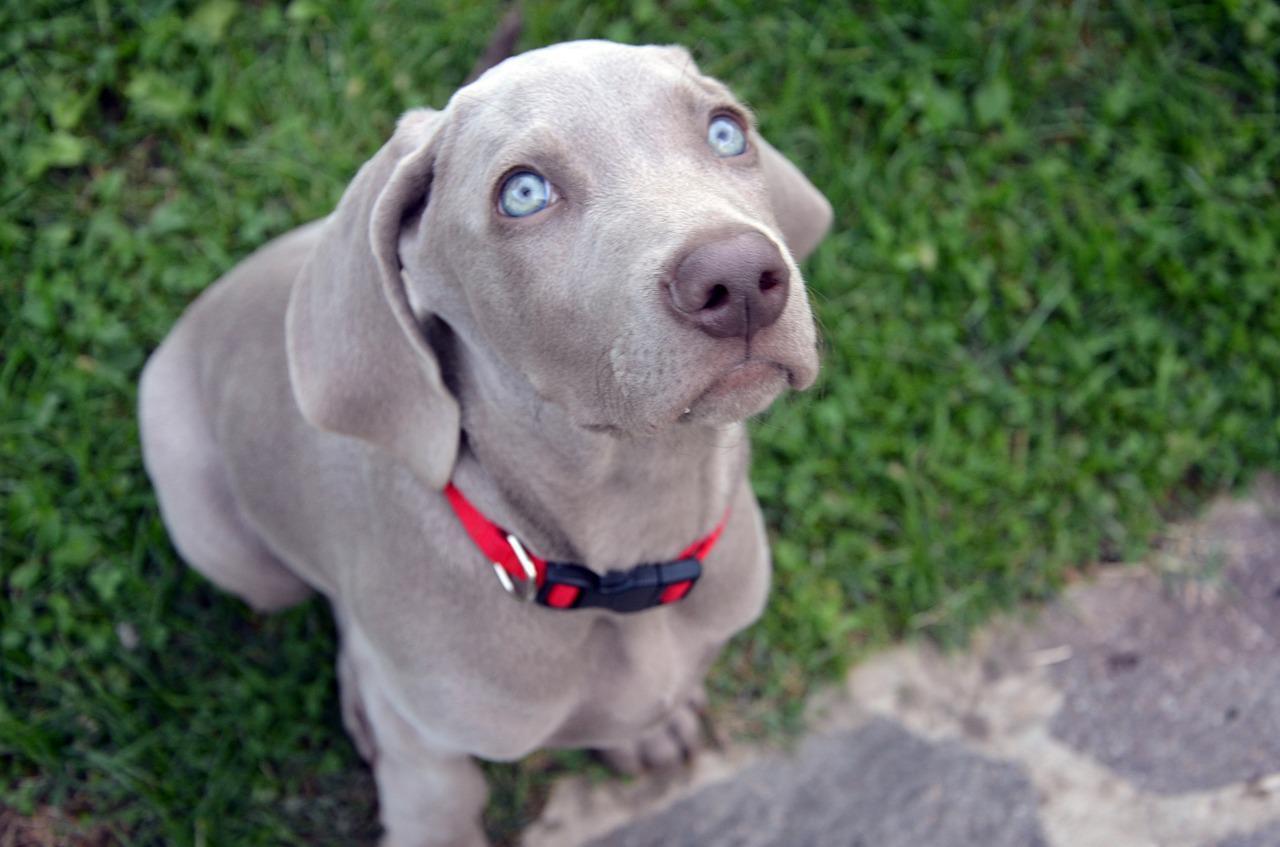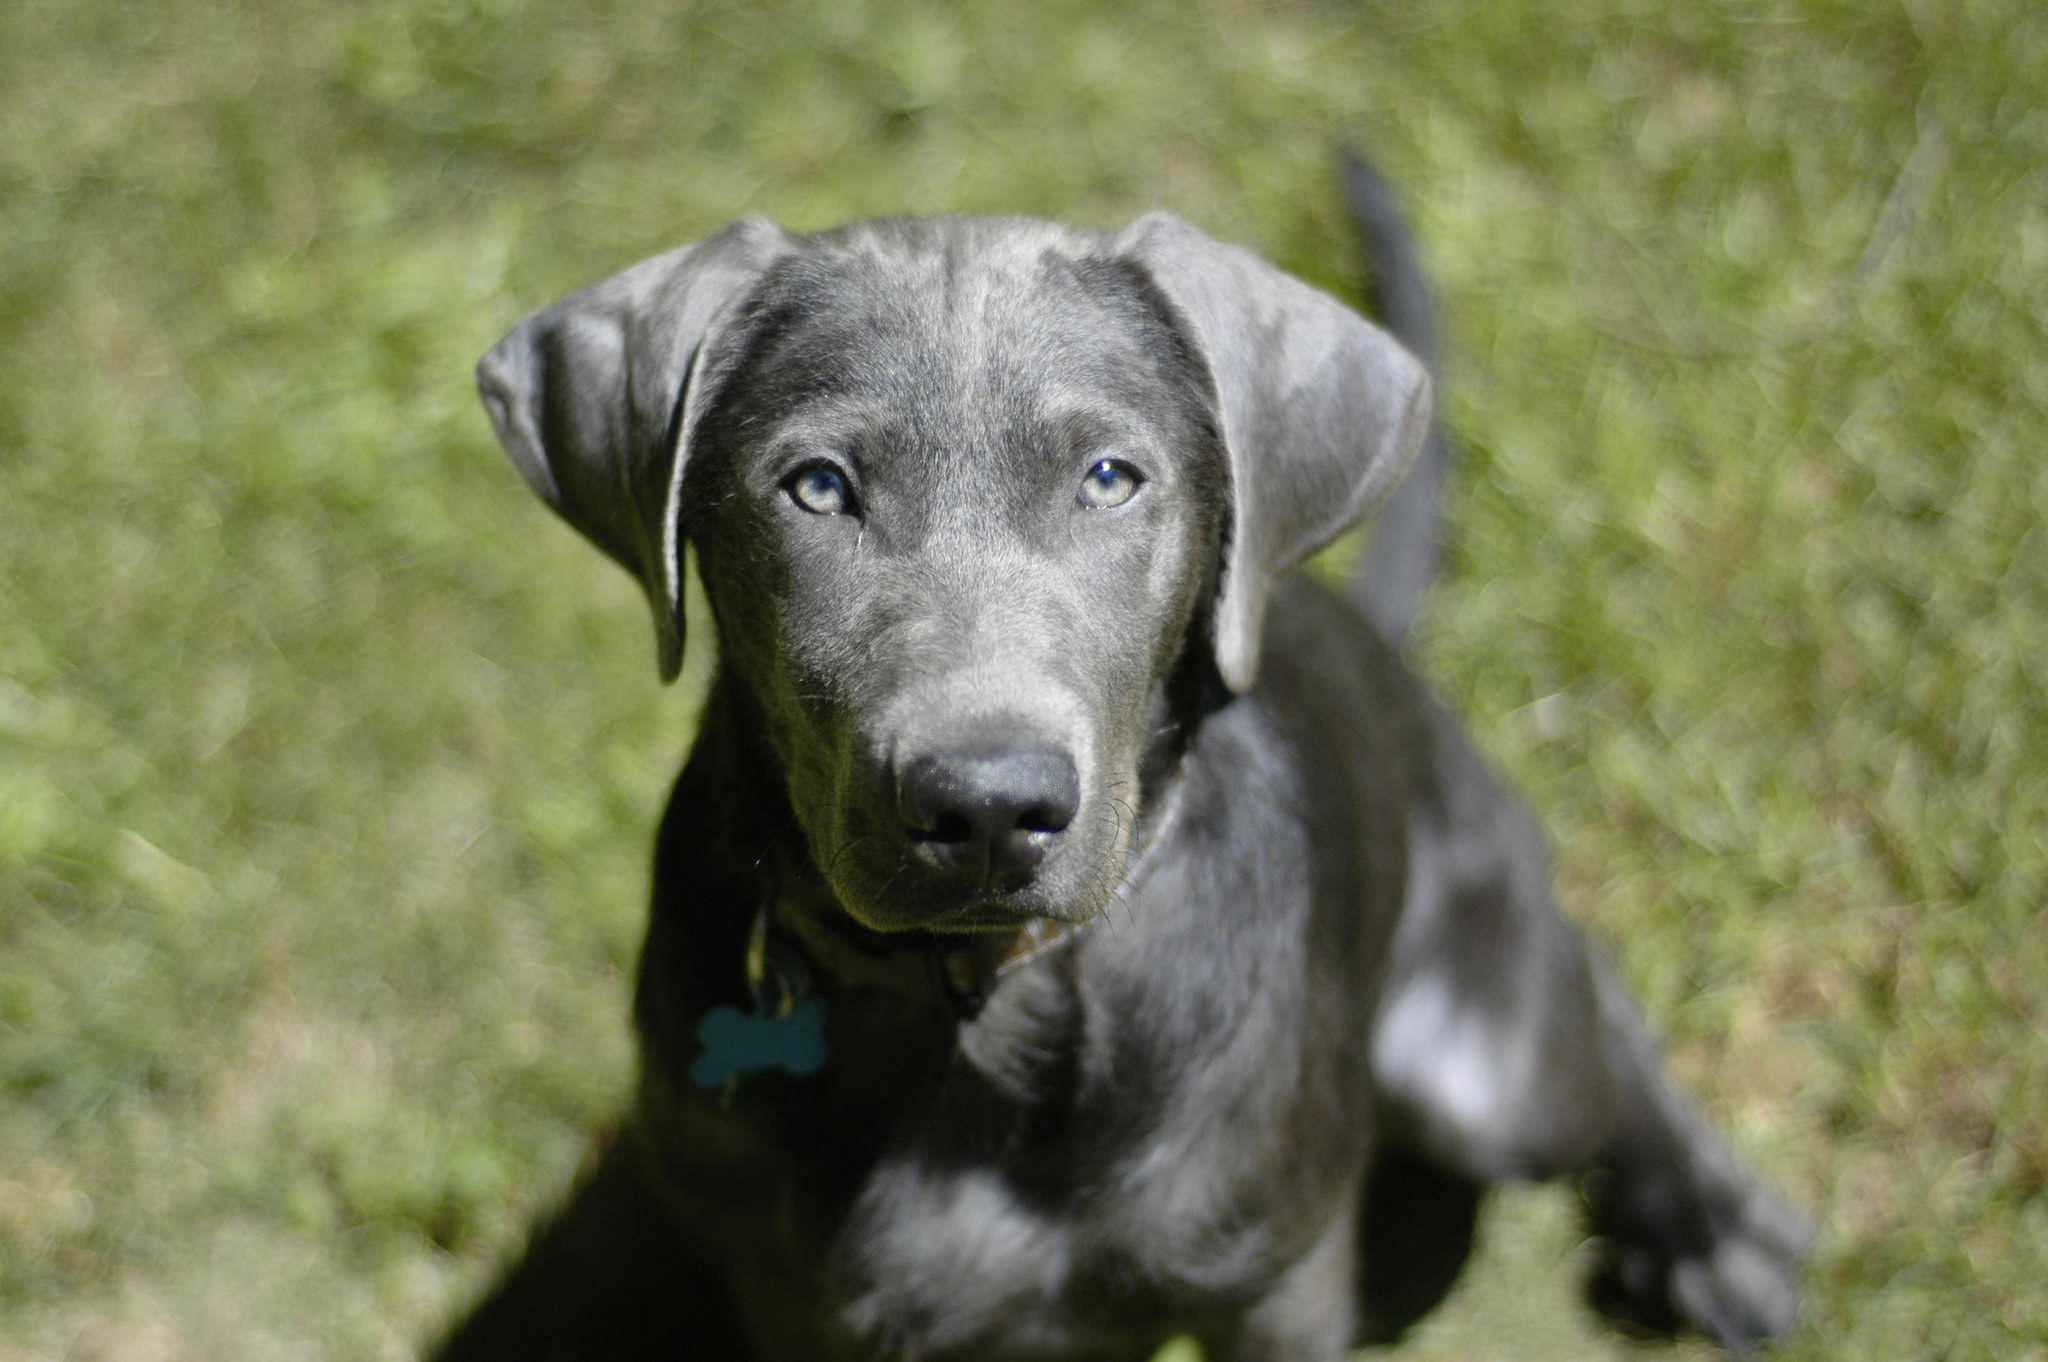The first image is the image on the left, the second image is the image on the right. For the images shown, is this caption "The dog in the left image is wearing a collar." true? Answer yes or no. Yes. The first image is the image on the left, the second image is the image on the right. For the images displayed, is the sentence "Each dog is posed outside with its head facing forward, and each dog wears a type of collar." factually correct? Answer yes or no. Yes. 